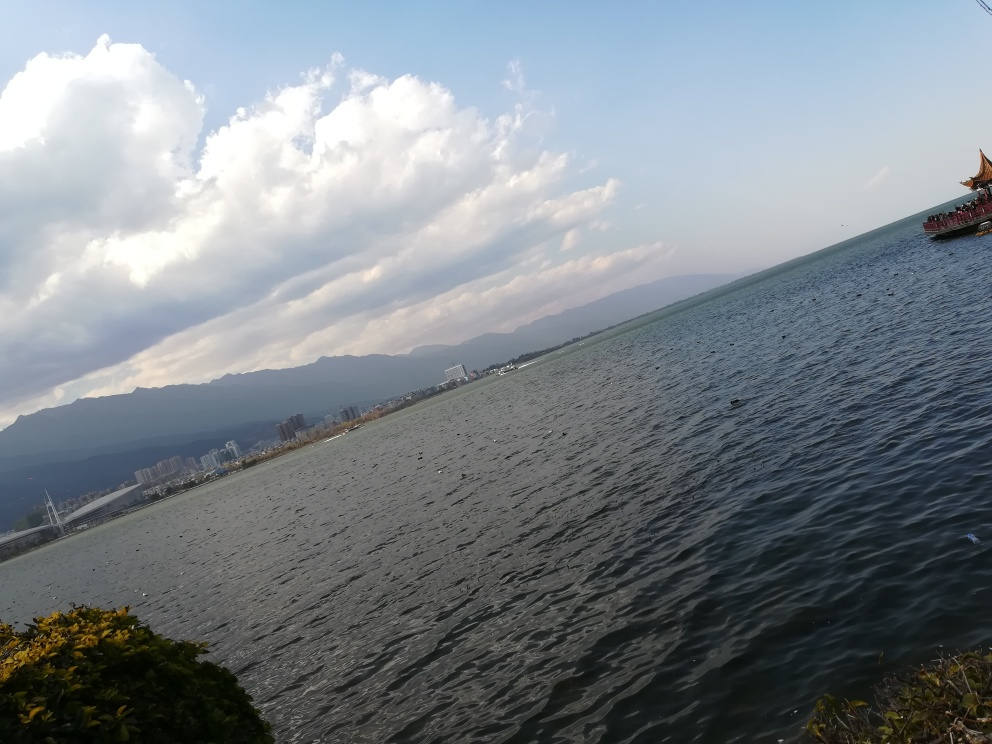What type of activities might take place on this body of water? Given the calm water and the presence of the traditional boat, activities could include sightseeing tours, leisurely boat rides, possibly some fishing, and canoeing or kayaking. 